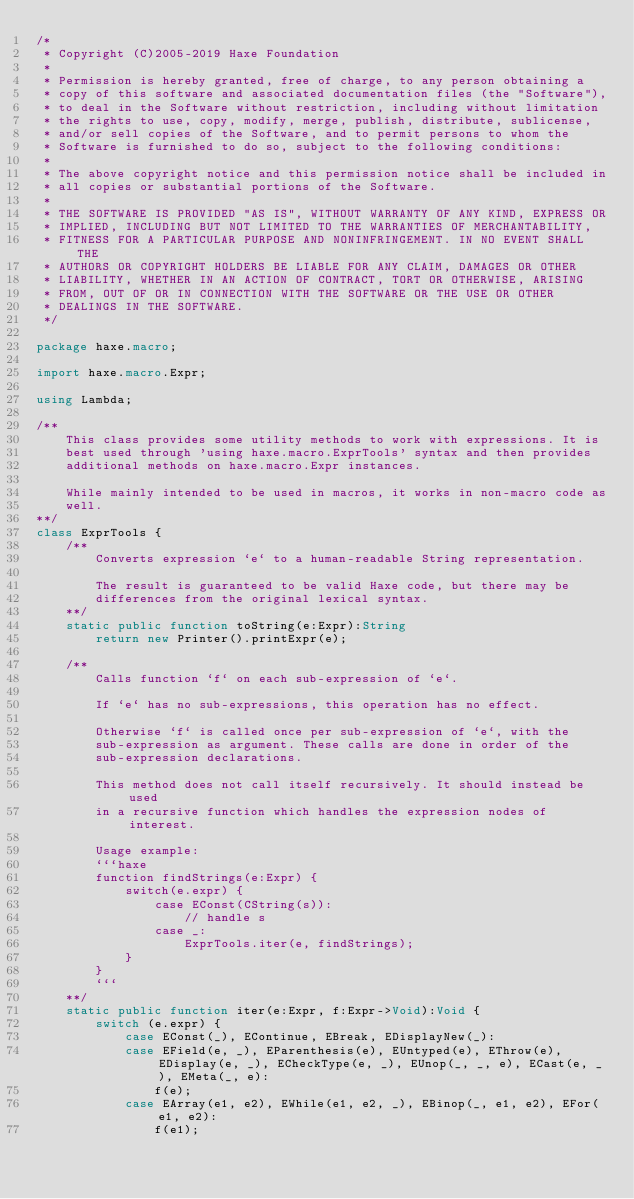Convert code to text. <code><loc_0><loc_0><loc_500><loc_500><_Haxe_>/*
 * Copyright (C)2005-2019 Haxe Foundation
 *
 * Permission is hereby granted, free of charge, to any person obtaining a
 * copy of this software and associated documentation files (the "Software"),
 * to deal in the Software without restriction, including without limitation
 * the rights to use, copy, modify, merge, publish, distribute, sublicense,
 * and/or sell copies of the Software, and to permit persons to whom the
 * Software is furnished to do so, subject to the following conditions:
 *
 * The above copyright notice and this permission notice shall be included in
 * all copies or substantial portions of the Software.
 *
 * THE SOFTWARE IS PROVIDED "AS IS", WITHOUT WARRANTY OF ANY KIND, EXPRESS OR
 * IMPLIED, INCLUDING BUT NOT LIMITED TO THE WARRANTIES OF MERCHANTABILITY,
 * FITNESS FOR A PARTICULAR PURPOSE AND NONINFRINGEMENT. IN NO EVENT SHALL THE
 * AUTHORS OR COPYRIGHT HOLDERS BE LIABLE FOR ANY CLAIM, DAMAGES OR OTHER
 * LIABILITY, WHETHER IN AN ACTION OF CONTRACT, TORT OR OTHERWISE, ARISING
 * FROM, OUT OF OR IN CONNECTION WITH THE SOFTWARE OR THE USE OR OTHER
 * DEALINGS IN THE SOFTWARE.
 */

package haxe.macro;

import haxe.macro.Expr;

using Lambda;

/**
	This class provides some utility methods to work with expressions. It is
	best used through 'using haxe.macro.ExprTools' syntax and then provides
	additional methods on haxe.macro.Expr instances.

	While mainly intended to be used in macros, it works in non-macro code as
	well.
**/
class ExprTools {
	/**
		Converts expression `e` to a human-readable String representation.

		The result is guaranteed to be valid Haxe code, but there may be
		differences from the original lexical syntax.
	**/
	static public function toString(e:Expr):String
		return new Printer().printExpr(e);

	/**
		Calls function `f` on each sub-expression of `e`.

		If `e` has no sub-expressions, this operation has no effect.

		Otherwise `f` is called once per sub-expression of `e`, with the
		sub-expression as argument. These calls are done in order of the
		sub-expression declarations.

		This method does not call itself recursively. It should instead be used
		in a recursive function which handles the expression nodes of interest.

		Usage example:
		```haxe
		function findStrings(e:Expr) {
			switch(e.expr) {
				case EConst(CString(s)):
					// handle s
				case _:
					ExprTools.iter(e, findStrings);
			}
		}
		```
	**/
	static public function iter(e:Expr, f:Expr->Void):Void {
		switch (e.expr) {
			case EConst(_), EContinue, EBreak, EDisplayNew(_):
			case EField(e, _), EParenthesis(e), EUntyped(e), EThrow(e), EDisplay(e, _), ECheckType(e, _), EUnop(_, _, e), ECast(e, _), EMeta(_, e):
				f(e);
			case EArray(e1, e2), EWhile(e1, e2, _), EBinop(_, e1, e2), EFor(e1, e2):
				f(e1);</code> 